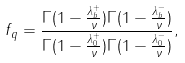Convert formula to latex. <formula><loc_0><loc_0><loc_500><loc_500>f _ { q } = \frac { \Gamma ( 1 - \frac { \lambda _ { b } ^ { + } } { \nu } ) \Gamma ( 1 - \frac { \lambda _ { b } ^ { - } } { \nu } ) } { \Gamma ( 1 - \frac { \lambda _ { 0 } ^ { + } } { \nu } ) \Gamma ( 1 - \frac { \lambda _ { 0 } ^ { - } } { \nu } ) } ,</formula> 